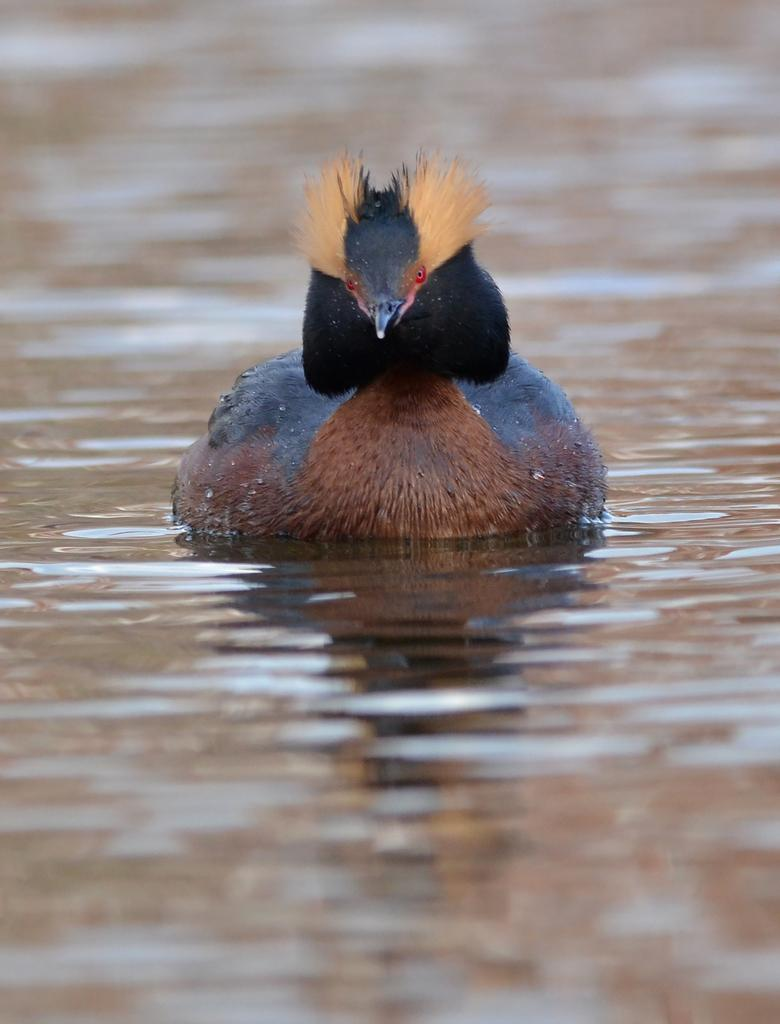Where was the image taken? The image is taken outdoors. What can be seen at the bottom of the image? There is a pond with water at the bottom of the image. What is present in the pond in the middle of the image? There is a bird in the pond in the middle of the image. What type of church can be seen in the background of the image? There is no church present in the image; it features a pond with a bird in it. What kind of brush is being used by the bird in the image? There is no brush present in the image, and the bird is not using any tool. 